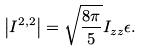Convert formula to latex. <formula><loc_0><loc_0><loc_500><loc_500>\left | I ^ { 2 , 2 } \right | = \sqrt { \frac { 8 \pi } { 5 } } I _ { z z } \epsilon .</formula> 